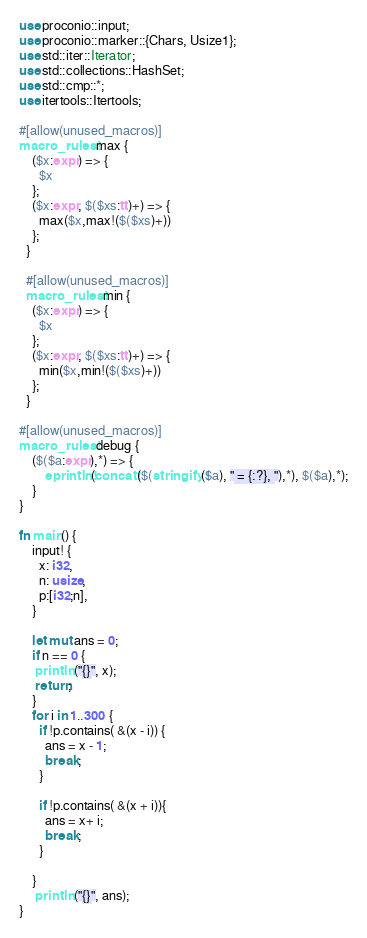<code> <loc_0><loc_0><loc_500><loc_500><_Rust_>use proconio::input;
use proconio::marker::{Chars, Usize1};
use std::iter::Iterator;
use std::collections::HashSet;
use std::cmp::*;
use itertools::Itertools;

#[allow(unused_macros)]
macro_rules! max {
    ($x:expr) => {
      $x
    };
    ($x:expr, $($xs:tt)+) => {
      max($x,max!($($xs)+))
    };
  }
  
  #[allow(unused_macros)]
  macro_rules! min {
    ($x:expr) => {
      $x
    };
    ($x:expr, $($xs:tt)+) => {
      min($x,min!($($xs)+))
    };
  }

#[allow(unused_macros)]
macro_rules! debug {
    ($($a:expr),*) => {
        eprintln!(concat!($(stringify!($a), " = {:?}, "),*), $($a),*);
    }
}

fn main() {
    input! {
      x: i32,
      n: usize,
      p:[i32;n],
    }

    let mut ans = 0;
    if n == 0 {
     println!("{}", x);
     return;
    }
    for i in 1..300 {
      if !p.contains( &(x - i)) {
        ans = x - 1;
        break;
      }

      if !p.contains( &(x + i)){
        ans = x+ i;
        break;
      }

    }
     println!("{}", ans);
}
</code> 